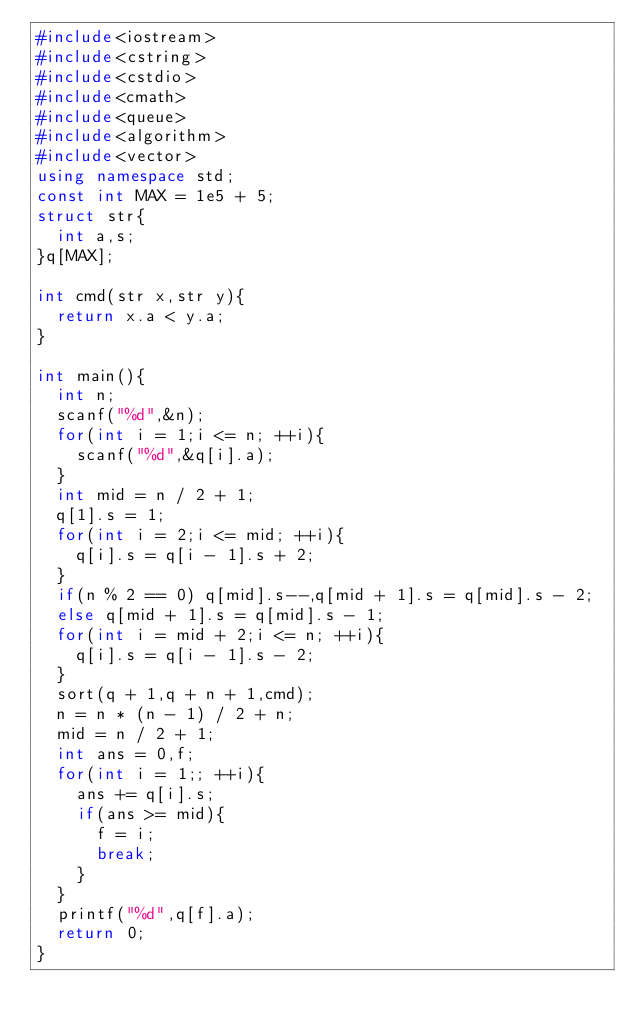<code> <loc_0><loc_0><loc_500><loc_500><_C++_>#include<iostream>
#include<cstring>
#include<cstdio>
#include<cmath>
#include<queue>
#include<algorithm>
#include<vector>
using namespace std;
const int MAX = 1e5 + 5;
struct str{
	int a,s;
}q[MAX];

int cmd(str x,str y){
	return x.a < y.a;
}

int main(){
	int n;
	scanf("%d",&n);
	for(int i = 1;i <= n; ++i){
		scanf("%d",&q[i].a);
	}
	int mid = n / 2 + 1;
	q[1].s = 1;
	for(int i = 2;i <= mid; ++i){
		q[i].s = q[i - 1].s + 2;
	}
	if(n % 2 == 0) q[mid].s--,q[mid + 1].s = q[mid].s - 2;
	else q[mid + 1].s = q[mid].s - 1;
	for(int i = mid + 2;i <= n; ++i){
		q[i].s = q[i - 1].s - 2;
	}
	sort(q + 1,q + n + 1,cmd);
	n = n * (n - 1) / 2 + n;
	mid = n / 2 + 1;
	int ans = 0,f;
	for(int i = 1;; ++i){
		ans += q[i].s;
		if(ans >= mid){
			f = i;
			break;
		}
	}
	printf("%d",q[f].a);
	return 0;
}</code> 